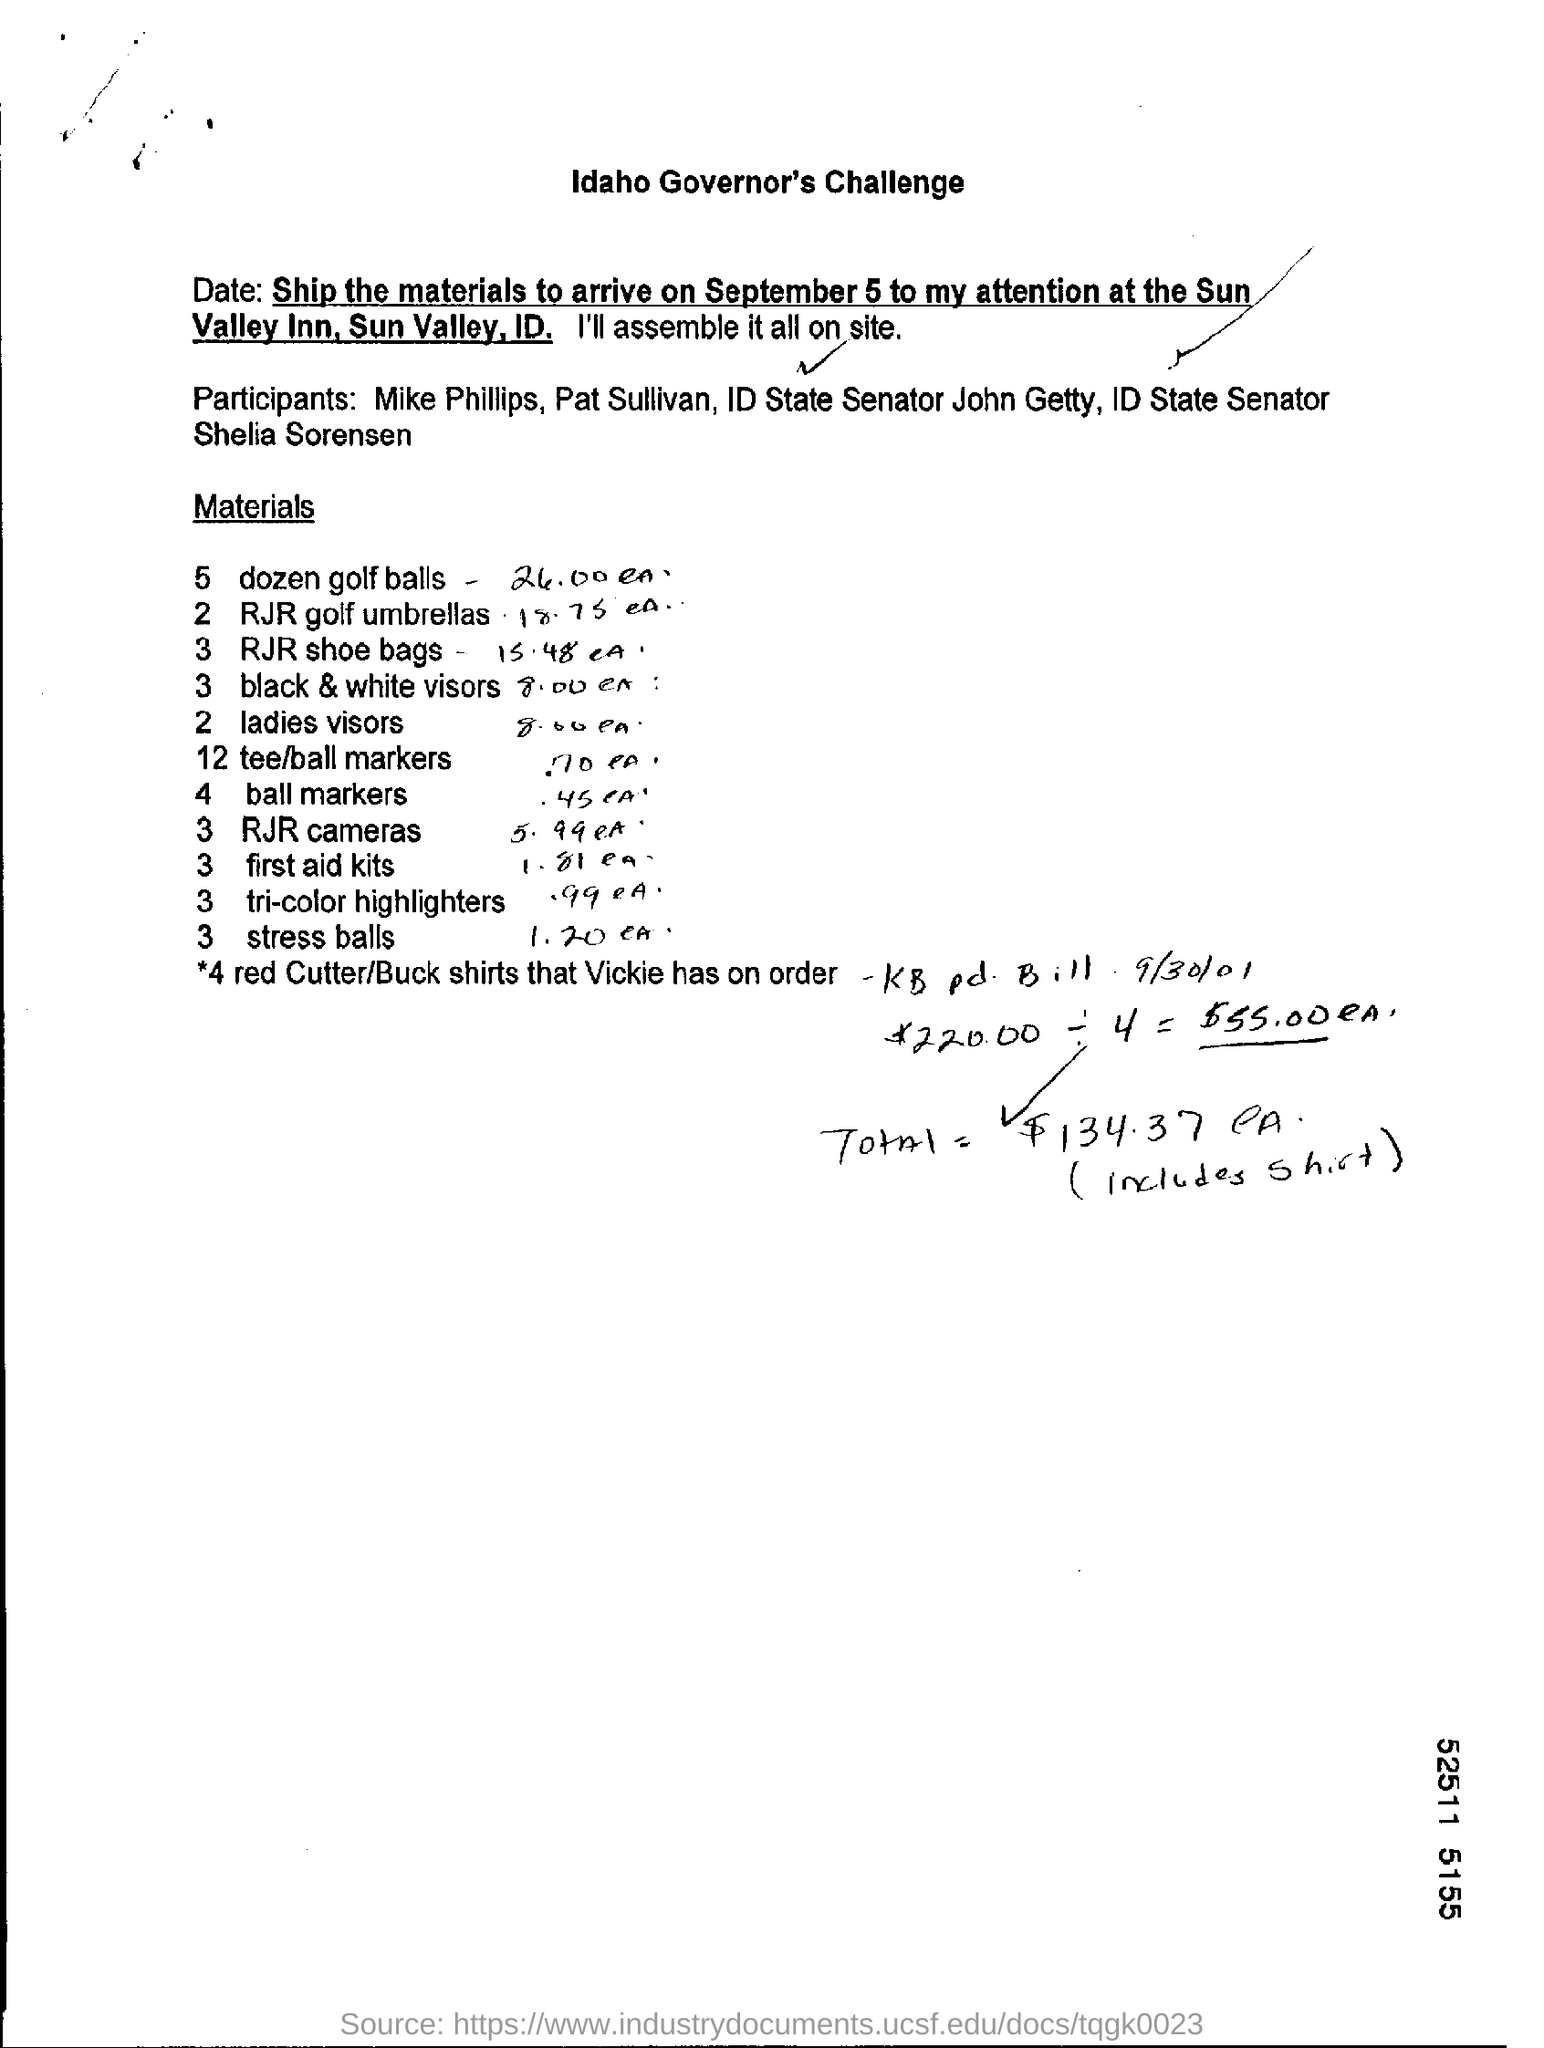Specify some key components in this picture. There are two RJR Golf umbrellas. There are a total of three RJR Shoe bags. There are three first aid kits present. It is imperative that the materials be shipped and arrive on September 5. There are two ladies' visors available. 